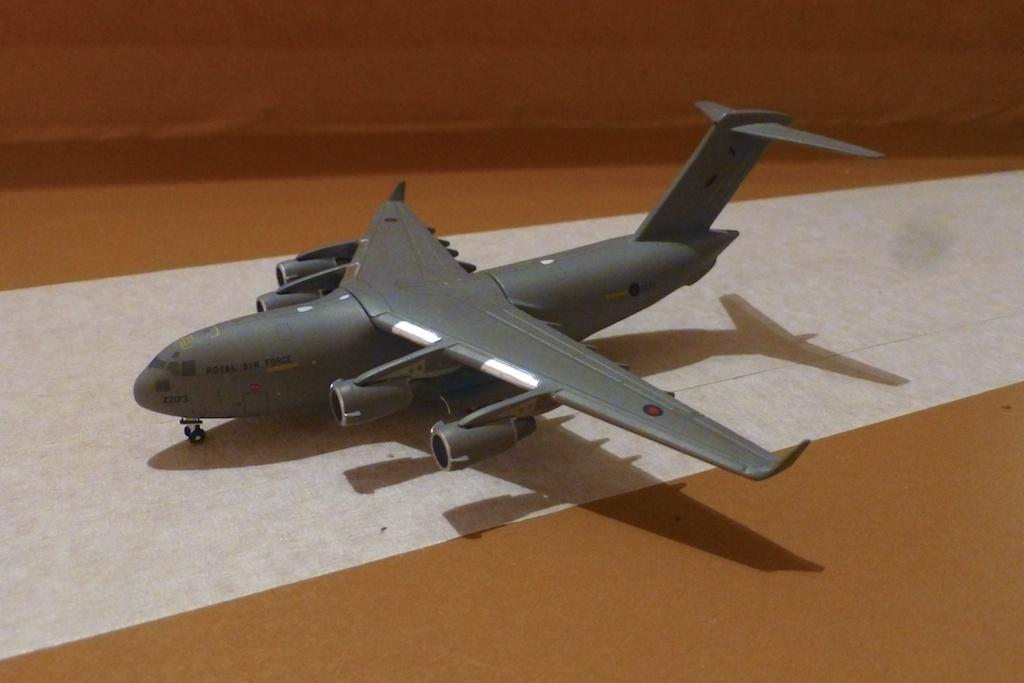What type of toy is present in the image? There is a toy aircraft in the image. What type of book is visible on the tail of the toy aircraft in the image? There is no book or tail present on the toy aircraft in the image. The toy aircraft is a single object, and there is no mention of any additional items or features. 